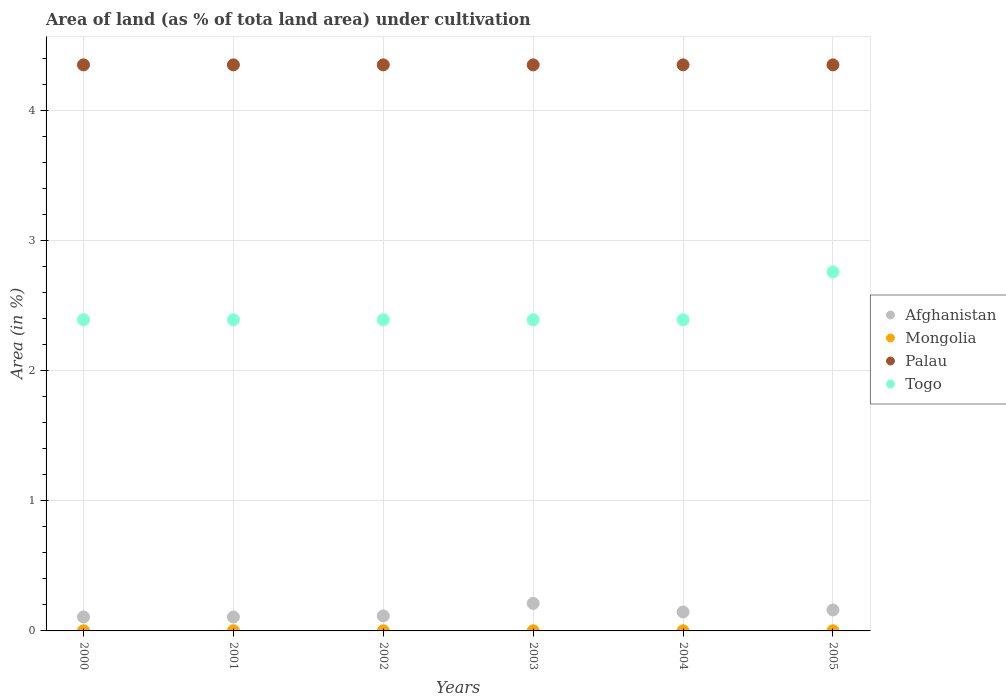What is the percentage of land under cultivation in Afghanistan in 2005?
Ensure brevity in your answer.  0.16. Across all years, what is the maximum percentage of land under cultivation in Afghanistan?
Your answer should be compact. 0.21. Across all years, what is the minimum percentage of land under cultivation in Mongolia?
Make the answer very short. 0. In which year was the percentage of land under cultivation in Togo maximum?
Your response must be concise. 2005. What is the total percentage of land under cultivation in Togo in the graph?
Give a very brief answer. 14.71. What is the difference between the percentage of land under cultivation in Afghanistan in 2000 and that in 2005?
Make the answer very short. -0.05. What is the difference between the percentage of land under cultivation in Afghanistan in 2003 and the percentage of land under cultivation in Mongolia in 2001?
Offer a very short reply. 0.21. What is the average percentage of land under cultivation in Afghanistan per year?
Provide a succinct answer. 0.14. In the year 2003, what is the difference between the percentage of land under cultivation in Afghanistan and percentage of land under cultivation in Mongolia?
Your response must be concise. 0.21. What is the ratio of the percentage of land under cultivation in Afghanistan in 2000 to that in 2005?
Give a very brief answer. 0.67. Is the percentage of land under cultivation in Mongolia in 2001 less than that in 2005?
Ensure brevity in your answer.  No. Is it the case that in every year, the sum of the percentage of land under cultivation in Palau and percentage of land under cultivation in Mongolia  is greater than the percentage of land under cultivation in Togo?
Your response must be concise. Yes. Is the percentage of land under cultivation in Palau strictly greater than the percentage of land under cultivation in Afghanistan over the years?
Make the answer very short. Yes. Is the percentage of land under cultivation in Mongolia strictly less than the percentage of land under cultivation in Togo over the years?
Your answer should be compact. Yes. How many dotlines are there?
Ensure brevity in your answer.  4. How many years are there in the graph?
Offer a very short reply. 6. Are the values on the major ticks of Y-axis written in scientific E-notation?
Give a very brief answer. No. Does the graph contain any zero values?
Offer a very short reply. No. Where does the legend appear in the graph?
Keep it short and to the point. Center right. How many legend labels are there?
Your answer should be compact. 4. How are the legend labels stacked?
Keep it short and to the point. Vertical. What is the title of the graph?
Give a very brief answer. Area of land (as % of tota land area) under cultivation. Does "Kiribati" appear as one of the legend labels in the graph?
Your answer should be compact. No. What is the label or title of the Y-axis?
Give a very brief answer. Area (in %). What is the Area (in %) of Afghanistan in 2000?
Give a very brief answer. 0.11. What is the Area (in %) of Mongolia in 2000?
Give a very brief answer. 0. What is the Area (in %) in Palau in 2000?
Provide a short and direct response. 4.35. What is the Area (in %) in Togo in 2000?
Your answer should be very brief. 2.39. What is the Area (in %) of Afghanistan in 2001?
Your answer should be compact. 0.11. What is the Area (in %) in Mongolia in 2001?
Keep it short and to the point. 0. What is the Area (in %) in Palau in 2001?
Provide a short and direct response. 4.35. What is the Area (in %) in Togo in 2001?
Ensure brevity in your answer.  2.39. What is the Area (in %) in Afghanistan in 2002?
Offer a terse response. 0.11. What is the Area (in %) in Mongolia in 2002?
Offer a terse response. 0. What is the Area (in %) of Palau in 2002?
Provide a short and direct response. 4.35. What is the Area (in %) in Togo in 2002?
Your response must be concise. 2.39. What is the Area (in %) in Afghanistan in 2003?
Give a very brief answer. 0.21. What is the Area (in %) in Mongolia in 2003?
Your answer should be compact. 0. What is the Area (in %) of Palau in 2003?
Your answer should be very brief. 4.35. What is the Area (in %) of Togo in 2003?
Your response must be concise. 2.39. What is the Area (in %) of Afghanistan in 2004?
Your answer should be very brief. 0.15. What is the Area (in %) in Mongolia in 2004?
Make the answer very short. 0. What is the Area (in %) in Palau in 2004?
Offer a terse response. 4.35. What is the Area (in %) of Togo in 2004?
Make the answer very short. 2.39. What is the Area (in %) in Afghanistan in 2005?
Offer a very short reply. 0.16. What is the Area (in %) of Mongolia in 2005?
Provide a short and direct response. 0. What is the Area (in %) in Palau in 2005?
Offer a very short reply. 4.35. What is the Area (in %) in Togo in 2005?
Keep it short and to the point. 2.76. Across all years, what is the maximum Area (in %) of Afghanistan?
Offer a terse response. 0.21. Across all years, what is the maximum Area (in %) in Mongolia?
Keep it short and to the point. 0. Across all years, what is the maximum Area (in %) of Palau?
Your answer should be compact. 4.35. Across all years, what is the maximum Area (in %) of Togo?
Offer a terse response. 2.76. Across all years, what is the minimum Area (in %) in Afghanistan?
Give a very brief answer. 0.11. Across all years, what is the minimum Area (in %) of Mongolia?
Give a very brief answer. 0. Across all years, what is the minimum Area (in %) of Palau?
Make the answer very short. 4.35. Across all years, what is the minimum Area (in %) in Togo?
Make the answer very short. 2.39. What is the total Area (in %) of Afghanistan in the graph?
Offer a very short reply. 0.85. What is the total Area (in %) in Mongolia in the graph?
Your response must be concise. 0.01. What is the total Area (in %) of Palau in the graph?
Your answer should be very brief. 26.09. What is the total Area (in %) of Togo in the graph?
Offer a very short reply. 14.71. What is the difference between the Area (in %) in Palau in 2000 and that in 2001?
Keep it short and to the point. 0. What is the difference between the Area (in %) of Togo in 2000 and that in 2001?
Your answer should be compact. 0. What is the difference between the Area (in %) of Afghanistan in 2000 and that in 2002?
Provide a succinct answer. -0.01. What is the difference between the Area (in %) of Togo in 2000 and that in 2002?
Offer a very short reply. 0. What is the difference between the Area (in %) of Afghanistan in 2000 and that in 2003?
Make the answer very short. -0.1. What is the difference between the Area (in %) in Mongolia in 2000 and that in 2003?
Make the answer very short. 0. What is the difference between the Area (in %) of Palau in 2000 and that in 2003?
Provide a short and direct response. 0. What is the difference between the Area (in %) in Afghanistan in 2000 and that in 2004?
Your answer should be very brief. -0.04. What is the difference between the Area (in %) of Afghanistan in 2000 and that in 2005?
Offer a very short reply. -0.05. What is the difference between the Area (in %) in Palau in 2000 and that in 2005?
Your answer should be compact. 0. What is the difference between the Area (in %) in Togo in 2000 and that in 2005?
Provide a short and direct response. -0.37. What is the difference between the Area (in %) in Afghanistan in 2001 and that in 2002?
Give a very brief answer. -0.01. What is the difference between the Area (in %) of Mongolia in 2001 and that in 2002?
Provide a short and direct response. 0. What is the difference between the Area (in %) in Palau in 2001 and that in 2002?
Provide a succinct answer. 0. What is the difference between the Area (in %) in Afghanistan in 2001 and that in 2003?
Give a very brief answer. -0.1. What is the difference between the Area (in %) in Mongolia in 2001 and that in 2003?
Offer a very short reply. 0. What is the difference between the Area (in %) of Palau in 2001 and that in 2003?
Provide a short and direct response. 0. What is the difference between the Area (in %) of Afghanistan in 2001 and that in 2004?
Provide a succinct answer. -0.04. What is the difference between the Area (in %) in Palau in 2001 and that in 2004?
Your answer should be very brief. 0. What is the difference between the Area (in %) in Togo in 2001 and that in 2004?
Keep it short and to the point. 0. What is the difference between the Area (in %) of Afghanistan in 2001 and that in 2005?
Offer a terse response. -0.05. What is the difference between the Area (in %) in Mongolia in 2001 and that in 2005?
Offer a terse response. 0. What is the difference between the Area (in %) of Palau in 2001 and that in 2005?
Your answer should be compact. 0. What is the difference between the Area (in %) of Togo in 2001 and that in 2005?
Give a very brief answer. -0.37. What is the difference between the Area (in %) of Afghanistan in 2002 and that in 2003?
Provide a short and direct response. -0.1. What is the difference between the Area (in %) of Mongolia in 2002 and that in 2003?
Provide a short and direct response. 0. What is the difference between the Area (in %) of Togo in 2002 and that in 2003?
Provide a succinct answer. 0. What is the difference between the Area (in %) of Afghanistan in 2002 and that in 2004?
Make the answer very short. -0.03. What is the difference between the Area (in %) of Palau in 2002 and that in 2004?
Keep it short and to the point. 0. What is the difference between the Area (in %) of Togo in 2002 and that in 2004?
Ensure brevity in your answer.  0. What is the difference between the Area (in %) in Afghanistan in 2002 and that in 2005?
Your answer should be compact. -0.05. What is the difference between the Area (in %) of Togo in 2002 and that in 2005?
Provide a succinct answer. -0.37. What is the difference between the Area (in %) in Afghanistan in 2003 and that in 2004?
Your response must be concise. 0.07. What is the difference between the Area (in %) of Afghanistan in 2003 and that in 2005?
Your answer should be compact. 0.05. What is the difference between the Area (in %) of Palau in 2003 and that in 2005?
Your response must be concise. 0. What is the difference between the Area (in %) in Togo in 2003 and that in 2005?
Offer a very short reply. -0.37. What is the difference between the Area (in %) in Afghanistan in 2004 and that in 2005?
Provide a succinct answer. -0.02. What is the difference between the Area (in %) of Palau in 2004 and that in 2005?
Keep it short and to the point. 0. What is the difference between the Area (in %) in Togo in 2004 and that in 2005?
Your answer should be very brief. -0.37. What is the difference between the Area (in %) in Afghanistan in 2000 and the Area (in %) in Mongolia in 2001?
Provide a short and direct response. 0.11. What is the difference between the Area (in %) in Afghanistan in 2000 and the Area (in %) in Palau in 2001?
Your answer should be compact. -4.24. What is the difference between the Area (in %) in Afghanistan in 2000 and the Area (in %) in Togo in 2001?
Your answer should be very brief. -2.28. What is the difference between the Area (in %) of Mongolia in 2000 and the Area (in %) of Palau in 2001?
Keep it short and to the point. -4.35. What is the difference between the Area (in %) in Mongolia in 2000 and the Area (in %) in Togo in 2001?
Offer a terse response. -2.39. What is the difference between the Area (in %) of Palau in 2000 and the Area (in %) of Togo in 2001?
Provide a short and direct response. 1.96. What is the difference between the Area (in %) of Afghanistan in 2000 and the Area (in %) of Mongolia in 2002?
Keep it short and to the point. 0.11. What is the difference between the Area (in %) in Afghanistan in 2000 and the Area (in %) in Palau in 2002?
Offer a terse response. -4.24. What is the difference between the Area (in %) in Afghanistan in 2000 and the Area (in %) in Togo in 2002?
Offer a very short reply. -2.28. What is the difference between the Area (in %) in Mongolia in 2000 and the Area (in %) in Palau in 2002?
Offer a very short reply. -4.35. What is the difference between the Area (in %) of Mongolia in 2000 and the Area (in %) of Togo in 2002?
Your answer should be very brief. -2.39. What is the difference between the Area (in %) of Palau in 2000 and the Area (in %) of Togo in 2002?
Make the answer very short. 1.96. What is the difference between the Area (in %) of Afghanistan in 2000 and the Area (in %) of Mongolia in 2003?
Keep it short and to the point. 0.11. What is the difference between the Area (in %) of Afghanistan in 2000 and the Area (in %) of Palau in 2003?
Provide a short and direct response. -4.24. What is the difference between the Area (in %) in Afghanistan in 2000 and the Area (in %) in Togo in 2003?
Your response must be concise. -2.28. What is the difference between the Area (in %) in Mongolia in 2000 and the Area (in %) in Palau in 2003?
Give a very brief answer. -4.35. What is the difference between the Area (in %) of Mongolia in 2000 and the Area (in %) of Togo in 2003?
Provide a succinct answer. -2.39. What is the difference between the Area (in %) in Palau in 2000 and the Area (in %) in Togo in 2003?
Make the answer very short. 1.96. What is the difference between the Area (in %) in Afghanistan in 2000 and the Area (in %) in Mongolia in 2004?
Offer a terse response. 0.11. What is the difference between the Area (in %) of Afghanistan in 2000 and the Area (in %) of Palau in 2004?
Offer a very short reply. -4.24. What is the difference between the Area (in %) in Afghanistan in 2000 and the Area (in %) in Togo in 2004?
Ensure brevity in your answer.  -2.28. What is the difference between the Area (in %) in Mongolia in 2000 and the Area (in %) in Palau in 2004?
Your response must be concise. -4.35. What is the difference between the Area (in %) in Mongolia in 2000 and the Area (in %) in Togo in 2004?
Provide a short and direct response. -2.39. What is the difference between the Area (in %) of Palau in 2000 and the Area (in %) of Togo in 2004?
Provide a succinct answer. 1.96. What is the difference between the Area (in %) in Afghanistan in 2000 and the Area (in %) in Mongolia in 2005?
Offer a terse response. 0.11. What is the difference between the Area (in %) of Afghanistan in 2000 and the Area (in %) of Palau in 2005?
Offer a very short reply. -4.24. What is the difference between the Area (in %) of Afghanistan in 2000 and the Area (in %) of Togo in 2005?
Give a very brief answer. -2.65. What is the difference between the Area (in %) in Mongolia in 2000 and the Area (in %) in Palau in 2005?
Ensure brevity in your answer.  -4.35. What is the difference between the Area (in %) in Mongolia in 2000 and the Area (in %) in Togo in 2005?
Your answer should be very brief. -2.76. What is the difference between the Area (in %) in Palau in 2000 and the Area (in %) in Togo in 2005?
Give a very brief answer. 1.59. What is the difference between the Area (in %) of Afghanistan in 2001 and the Area (in %) of Mongolia in 2002?
Make the answer very short. 0.11. What is the difference between the Area (in %) of Afghanistan in 2001 and the Area (in %) of Palau in 2002?
Provide a succinct answer. -4.24. What is the difference between the Area (in %) of Afghanistan in 2001 and the Area (in %) of Togo in 2002?
Keep it short and to the point. -2.28. What is the difference between the Area (in %) of Mongolia in 2001 and the Area (in %) of Palau in 2002?
Offer a terse response. -4.35. What is the difference between the Area (in %) in Mongolia in 2001 and the Area (in %) in Togo in 2002?
Keep it short and to the point. -2.39. What is the difference between the Area (in %) in Palau in 2001 and the Area (in %) in Togo in 2002?
Make the answer very short. 1.96. What is the difference between the Area (in %) in Afghanistan in 2001 and the Area (in %) in Mongolia in 2003?
Offer a very short reply. 0.11. What is the difference between the Area (in %) in Afghanistan in 2001 and the Area (in %) in Palau in 2003?
Provide a short and direct response. -4.24. What is the difference between the Area (in %) in Afghanistan in 2001 and the Area (in %) in Togo in 2003?
Ensure brevity in your answer.  -2.28. What is the difference between the Area (in %) in Mongolia in 2001 and the Area (in %) in Palau in 2003?
Ensure brevity in your answer.  -4.35. What is the difference between the Area (in %) in Mongolia in 2001 and the Area (in %) in Togo in 2003?
Make the answer very short. -2.39. What is the difference between the Area (in %) in Palau in 2001 and the Area (in %) in Togo in 2003?
Your answer should be compact. 1.96. What is the difference between the Area (in %) of Afghanistan in 2001 and the Area (in %) of Mongolia in 2004?
Make the answer very short. 0.11. What is the difference between the Area (in %) of Afghanistan in 2001 and the Area (in %) of Palau in 2004?
Provide a short and direct response. -4.24. What is the difference between the Area (in %) in Afghanistan in 2001 and the Area (in %) in Togo in 2004?
Your response must be concise. -2.28. What is the difference between the Area (in %) of Mongolia in 2001 and the Area (in %) of Palau in 2004?
Keep it short and to the point. -4.35. What is the difference between the Area (in %) of Mongolia in 2001 and the Area (in %) of Togo in 2004?
Give a very brief answer. -2.39. What is the difference between the Area (in %) of Palau in 2001 and the Area (in %) of Togo in 2004?
Ensure brevity in your answer.  1.96. What is the difference between the Area (in %) in Afghanistan in 2001 and the Area (in %) in Mongolia in 2005?
Your response must be concise. 0.11. What is the difference between the Area (in %) in Afghanistan in 2001 and the Area (in %) in Palau in 2005?
Your answer should be compact. -4.24. What is the difference between the Area (in %) in Afghanistan in 2001 and the Area (in %) in Togo in 2005?
Your answer should be very brief. -2.65. What is the difference between the Area (in %) in Mongolia in 2001 and the Area (in %) in Palau in 2005?
Keep it short and to the point. -4.35. What is the difference between the Area (in %) of Mongolia in 2001 and the Area (in %) of Togo in 2005?
Your answer should be compact. -2.76. What is the difference between the Area (in %) of Palau in 2001 and the Area (in %) of Togo in 2005?
Your response must be concise. 1.59. What is the difference between the Area (in %) in Afghanistan in 2002 and the Area (in %) in Mongolia in 2003?
Keep it short and to the point. 0.11. What is the difference between the Area (in %) of Afghanistan in 2002 and the Area (in %) of Palau in 2003?
Keep it short and to the point. -4.23. What is the difference between the Area (in %) in Afghanistan in 2002 and the Area (in %) in Togo in 2003?
Your answer should be compact. -2.28. What is the difference between the Area (in %) of Mongolia in 2002 and the Area (in %) of Palau in 2003?
Your response must be concise. -4.35. What is the difference between the Area (in %) in Mongolia in 2002 and the Area (in %) in Togo in 2003?
Ensure brevity in your answer.  -2.39. What is the difference between the Area (in %) of Palau in 2002 and the Area (in %) of Togo in 2003?
Your answer should be very brief. 1.96. What is the difference between the Area (in %) in Afghanistan in 2002 and the Area (in %) in Mongolia in 2004?
Your answer should be very brief. 0.11. What is the difference between the Area (in %) of Afghanistan in 2002 and the Area (in %) of Palau in 2004?
Provide a succinct answer. -4.23. What is the difference between the Area (in %) in Afghanistan in 2002 and the Area (in %) in Togo in 2004?
Your answer should be compact. -2.28. What is the difference between the Area (in %) of Mongolia in 2002 and the Area (in %) of Palau in 2004?
Your answer should be compact. -4.35. What is the difference between the Area (in %) of Mongolia in 2002 and the Area (in %) of Togo in 2004?
Provide a short and direct response. -2.39. What is the difference between the Area (in %) of Palau in 2002 and the Area (in %) of Togo in 2004?
Offer a terse response. 1.96. What is the difference between the Area (in %) in Afghanistan in 2002 and the Area (in %) in Mongolia in 2005?
Give a very brief answer. 0.11. What is the difference between the Area (in %) in Afghanistan in 2002 and the Area (in %) in Palau in 2005?
Provide a short and direct response. -4.23. What is the difference between the Area (in %) in Afghanistan in 2002 and the Area (in %) in Togo in 2005?
Your answer should be compact. -2.64. What is the difference between the Area (in %) in Mongolia in 2002 and the Area (in %) in Palau in 2005?
Provide a short and direct response. -4.35. What is the difference between the Area (in %) in Mongolia in 2002 and the Area (in %) in Togo in 2005?
Your answer should be very brief. -2.76. What is the difference between the Area (in %) of Palau in 2002 and the Area (in %) of Togo in 2005?
Provide a succinct answer. 1.59. What is the difference between the Area (in %) in Afghanistan in 2003 and the Area (in %) in Mongolia in 2004?
Provide a short and direct response. 0.21. What is the difference between the Area (in %) in Afghanistan in 2003 and the Area (in %) in Palau in 2004?
Provide a short and direct response. -4.14. What is the difference between the Area (in %) in Afghanistan in 2003 and the Area (in %) in Togo in 2004?
Your answer should be very brief. -2.18. What is the difference between the Area (in %) of Mongolia in 2003 and the Area (in %) of Palau in 2004?
Provide a succinct answer. -4.35. What is the difference between the Area (in %) in Mongolia in 2003 and the Area (in %) in Togo in 2004?
Make the answer very short. -2.39. What is the difference between the Area (in %) in Palau in 2003 and the Area (in %) in Togo in 2004?
Keep it short and to the point. 1.96. What is the difference between the Area (in %) of Afghanistan in 2003 and the Area (in %) of Mongolia in 2005?
Make the answer very short. 0.21. What is the difference between the Area (in %) of Afghanistan in 2003 and the Area (in %) of Palau in 2005?
Offer a very short reply. -4.14. What is the difference between the Area (in %) of Afghanistan in 2003 and the Area (in %) of Togo in 2005?
Your answer should be compact. -2.55. What is the difference between the Area (in %) in Mongolia in 2003 and the Area (in %) in Palau in 2005?
Your answer should be very brief. -4.35. What is the difference between the Area (in %) of Mongolia in 2003 and the Area (in %) of Togo in 2005?
Your response must be concise. -2.76. What is the difference between the Area (in %) in Palau in 2003 and the Area (in %) in Togo in 2005?
Provide a succinct answer. 1.59. What is the difference between the Area (in %) of Afghanistan in 2004 and the Area (in %) of Mongolia in 2005?
Offer a terse response. 0.14. What is the difference between the Area (in %) of Afghanistan in 2004 and the Area (in %) of Palau in 2005?
Your response must be concise. -4.2. What is the difference between the Area (in %) of Afghanistan in 2004 and the Area (in %) of Togo in 2005?
Keep it short and to the point. -2.61. What is the difference between the Area (in %) in Mongolia in 2004 and the Area (in %) in Palau in 2005?
Provide a succinct answer. -4.35. What is the difference between the Area (in %) of Mongolia in 2004 and the Area (in %) of Togo in 2005?
Your response must be concise. -2.76. What is the difference between the Area (in %) of Palau in 2004 and the Area (in %) of Togo in 2005?
Provide a short and direct response. 1.59. What is the average Area (in %) of Afghanistan per year?
Offer a very short reply. 0.14. What is the average Area (in %) in Mongolia per year?
Give a very brief answer. 0. What is the average Area (in %) of Palau per year?
Your answer should be very brief. 4.35. What is the average Area (in %) of Togo per year?
Make the answer very short. 2.45. In the year 2000, what is the difference between the Area (in %) of Afghanistan and Area (in %) of Mongolia?
Your response must be concise. 0.11. In the year 2000, what is the difference between the Area (in %) of Afghanistan and Area (in %) of Palau?
Your response must be concise. -4.24. In the year 2000, what is the difference between the Area (in %) of Afghanistan and Area (in %) of Togo?
Give a very brief answer. -2.28. In the year 2000, what is the difference between the Area (in %) of Mongolia and Area (in %) of Palau?
Your answer should be very brief. -4.35. In the year 2000, what is the difference between the Area (in %) of Mongolia and Area (in %) of Togo?
Your answer should be very brief. -2.39. In the year 2000, what is the difference between the Area (in %) of Palau and Area (in %) of Togo?
Provide a short and direct response. 1.96. In the year 2001, what is the difference between the Area (in %) of Afghanistan and Area (in %) of Mongolia?
Your answer should be very brief. 0.11. In the year 2001, what is the difference between the Area (in %) in Afghanistan and Area (in %) in Palau?
Keep it short and to the point. -4.24. In the year 2001, what is the difference between the Area (in %) of Afghanistan and Area (in %) of Togo?
Your answer should be very brief. -2.28. In the year 2001, what is the difference between the Area (in %) of Mongolia and Area (in %) of Palau?
Your answer should be very brief. -4.35. In the year 2001, what is the difference between the Area (in %) in Mongolia and Area (in %) in Togo?
Your response must be concise. -2.39. In the year 2001, what is the difference between the Area (in %) in Palau and Area (in %) in Togo?
Your answer should be compact. 1.96. In the year 2002, what is the difference between the Area (in %) in Afghanistan and Area (in %) in Mongolia?
Your answer should be compact. 0.11. In the year 2002, what is the difference between the Area (in %) in Afghanistan and Area (in %) in Palau?
Keep it short and to the point. -4.23. In the year 2002, what is the difference between the Area (in %) in Afghanistan and Area (in %) in Togo?
Offer a very short reply. -2.28. In the year 2002, what is the difference between the Area (in %) in Mongolia and Area (in %) in Palau?
Keep it short and to the point. -4.35. In the year 2002, what is the difference between the Area (in %) of Mongolia and Area (in %) of Togo?
Provide a succinct answer. -2.39. In the year 2002, what is the difference between the Area (in %) in Palau and Area (in %) in Togo?
Offer a terse response. 1.96. In the year 2003, what is the difference between the Area (in %) in Afghanistan and Area (in %) in Mongolia?
Make the answer very short. 0.21. In the year 2003, what is the difference between the Area (in %) of Afghanistan and Area (in %) of Palau?
Provide a short and direct response. -4.14. In the year 2003, what is the difference between the Area (in %) of Afghanistan and Area (in %) of Togo?
Your answer should be very brief. -2.18. In the year 2003, what is the difference between the Area (in %) in Mongolia and Area (in %) in Palau?
Your response must be concise. -4.35. In the year 2003, what is the difference between the Area (in %) of Mongolia and Area (in %) of Togo?
Give a very brief answer. -2.39. In the year 2003, what is the difference between the Area (in %) of Palau and Area (in %) of Togo?
Make the answer very short. 1.96. In the year 2004, what is the difference between the Area (in %) in Afghanistan and Area (in %) in Mongolia?
Your response must be concise. 0.14. In the year 2004, what is the difference between the Area (in %) in Afghanistan and Area (in %) in Palau?
Your response must be concise. -4.2. In the year 2004, what is the difference between the Area (in %) of Afghanistan and Area (in %) of Togo?
Ensure brevity in your answer.  -2.24. In the year 2004, what is the difference between the Area (in %) in Mongolia and Area (in %) in Palau?
Your answer should be very brief. -4.35. In the year 2004, what is the difference between the Area (in %) in Mongolia and Area (in %) in Togo?
Provide a short and direct response. -2.39. In the year 2004, what is the difference between the Area (in %) of Palau and Area (in %) of Togo?
Your answer should be very brief. 1.96. In the year 2005, what is the difference between the Area (in %) in Afghanistan and Area (in %) in Mongolia?
Ensure brevity in your answer.  0.16. In the year 2005, what is the difference between the Area (in %) in Afghanistan and Area (in %) in Palau?
Provide a short and direct response. -4.19. In the year 2005, what is the difference between the Area (in %) of Afghanistan and Area (in %) of Togo?
Provide a short and direct response. -2.6. In the year 2005, what is the difference between the Area (in %) in Mongolia and Area (in %) in Palau?
Provide a short and direct response. -4.35. In the year 2005, what is the difference between the Area (in %) of Mongolia and Area (in %) of Togo?
Offer a very short reply. -2.76. In the year 2005, what is the difference between the Area (in %) of Palau and Area (in %) of Togo?
Provide a short and direct response. 1.59. What is the ratio of the Area (in %) of Palau in 2000 to that in 2001?
Your answer should be very brief. 1. What is the ratio of the Area (in %) in Palau in 2000 to that in 2002?
Your answer should be compact. 1. What is the ratio of the Area (in %) in Afghanistan in 2000 to that in 2003?
Offer a very short reply. 0.51. What is the ratio of the Area (in %) in Mongolia in 2000 to that in 2003?
Offer a terse response. 1. What is the ratio of the Area (in %) of Palau in 2000 to that in 2003?
Your response must be concise. 1. What is the ratio of the Area (in %) in Togo in 2000 to that in 2003?
Make the answer very short. 1. What is the ratio of the Area (in %) of Afghanistan in 2000 to that in 2004?
Your answer should be very brief. 0.74. What is the ratio of the Area (in %) of Palau in 2000 to that in 2004?
Ensure brevity in your answer.  1. What is the ratio of the Area (in %) in Togo in 2000 to that in 2004?
Ensure brevity in your answer.  1. What is the ratio of the Area (in %) of Afghanistan in 2000 to that in 2005?
Your answer should be very brief. 0.67. What is the ratio of the Area (in %) in Togo in 2000 to that in 2005?
Provide a succinct answer. 0.87. What is the ratio of the Area (in %) in Afghanistan in 2001 to that in 2003?
Your answer should be very brief. 0.51. What is the ratio of the Area (in %) of Palau in 2001 to that in 2003?
Your answer should be compact. 1. What is the ratio of the Area (in %) in Togo in 2001 to that in 2003?
Give a very brief answer. 1. What is the ratio of the Area (in %) of Afghanistan in 2001 to that in 2004?
Ensure brevity in your answer.  0.74. What is the ratio of the Area (in %) of Togo in 2001 to that in 2004?
Give a very brief answer. 1. What is the ratio of the Area (in %) in Mongolia in 2001 to that in 2005?
Ensure brevity in your answer.  1. What is the ratio of the Area (in %) in Palau in 2001 to that in 2005?
Give a very brief answer. 1. What is the ratio of the Area (in %) of Togo in 2001 to that in 2005?
Your answer should be very brief. 0.87. What is the ratio of the Area (in %) in Afghanistan in 2002 to that in 2003?
Give a very brief answer. 0.54. What is the ratio of the Area (in %) of Togo in 2002 to that in 2003?
Your answer should be compact. 1. What is the ratio of the Area (in %) of Afghanistan in 2002 to that in 2004?
Provide a short and direct response. 0.79. What is the ratio of the Area (in %) in Mongolia in 2002 to that in 2004?
Ensure brevity in your answer.  1. What is the ratio of the Area (in %) of Togo in 2002 to that in 2004?
Make the answer very short. 1. What is the ratio of the Area (in %) in Afghanistan in 2002 to that in 2005?
Offer a terse response. 0.71. What is the ratio of the Area (in %) in Mongolia in 2002 to that in 2005?
Your answer should be compact. 1. What is the ratio of the Area (in %) of Togo in 2002 to that in 2005?
Your answer should be compact. 0.87. What is the ratio of the Area (in %) in Afghanistan in 2003 to that in 2004?
Your response must be concise. 1.45. What is the ratio of the Area (in %) in Mongolia in 2003 to that in 2004?
Offer a very short reply. 1. What is the ratio of the Area (in %) in Palau in 2003 to that in 2004?
Offer a terse response. 1. What is the ratio of the Area (in %) of Togo in 2003 to that in 2004?
Give a very brief answer. 1. What is the ratio of the Area (in %) of Afghanistan in 2003 to that in 2005?
Provide a succinct answer. 1.31. What is the ratio of the Area (in %) in Mongolia in 2003 to that in 2005?
Offer a terse response. 1. What is the ratio of the Area (in %) in Palau in 2003 to that in 2005?
Your response must be concise. 1. What is the ratio of the Area (in %) of Togo in 2003 to that in 2005?
Ensure brevity in your answer.  0.87. What is the ratio of the Area (in %) of Afghanistan in 2004 to that in 2005?
Your response must be concise. 0.9. What is the ratio of the Area (in %) of Mongolia in 2004 to that in 2005?
Offer a terse response. 1. What is the ratio of the Area (in %) in Togo in 2004 to that in 2005?
Your answer should be very brief. 0.87. What is the difference between the highest and the second highest Area (in %) of Afghanistan?
Provide a short and direct response. 0.05. What is the difference between the highest and the second highest Area (in %) in Mongolia?
Ensure brevity in your answer.  0. What is the difference between the highest and the second highest Area (in %) of Togo?
Provide a short and direct response. 0.37. What is the difference between the highest and the lowest Area (in %) of Afghanistan?
Provide a short and direct response. 0.1. What is the difference between the highest and the lowest Area (in %) of Palau?
Your answer should be compact. 0. What is the difference between the highest and the lowest Area (in %) of Togo?
Provide a short and direct response. 0.37. 